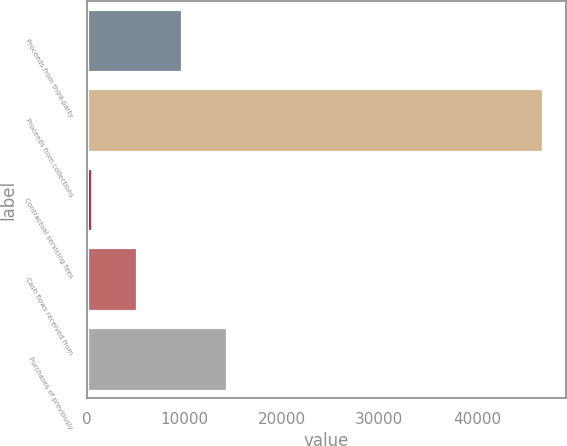<chart> <loc_0><loc_0><loc_500><loc_500><bar_chart><fcel>Proceeds from third-party<fcel>Proceeds from collections<fcel>Contractual servicing fees<fcel>Cash flows received from<fcel>Purchases of previously<nl><fcel>9742.6<fcel>46753<fcel>490<fcel>5116.3<fcel>14368.9<nl></chart> 